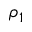<formula> <loc_0><loc_0><loc_500><loc_500>\rho _ { 1 }</formula> 